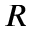<formula> <loc_0><loc_0><loc_500><loc_500>R</formula> 